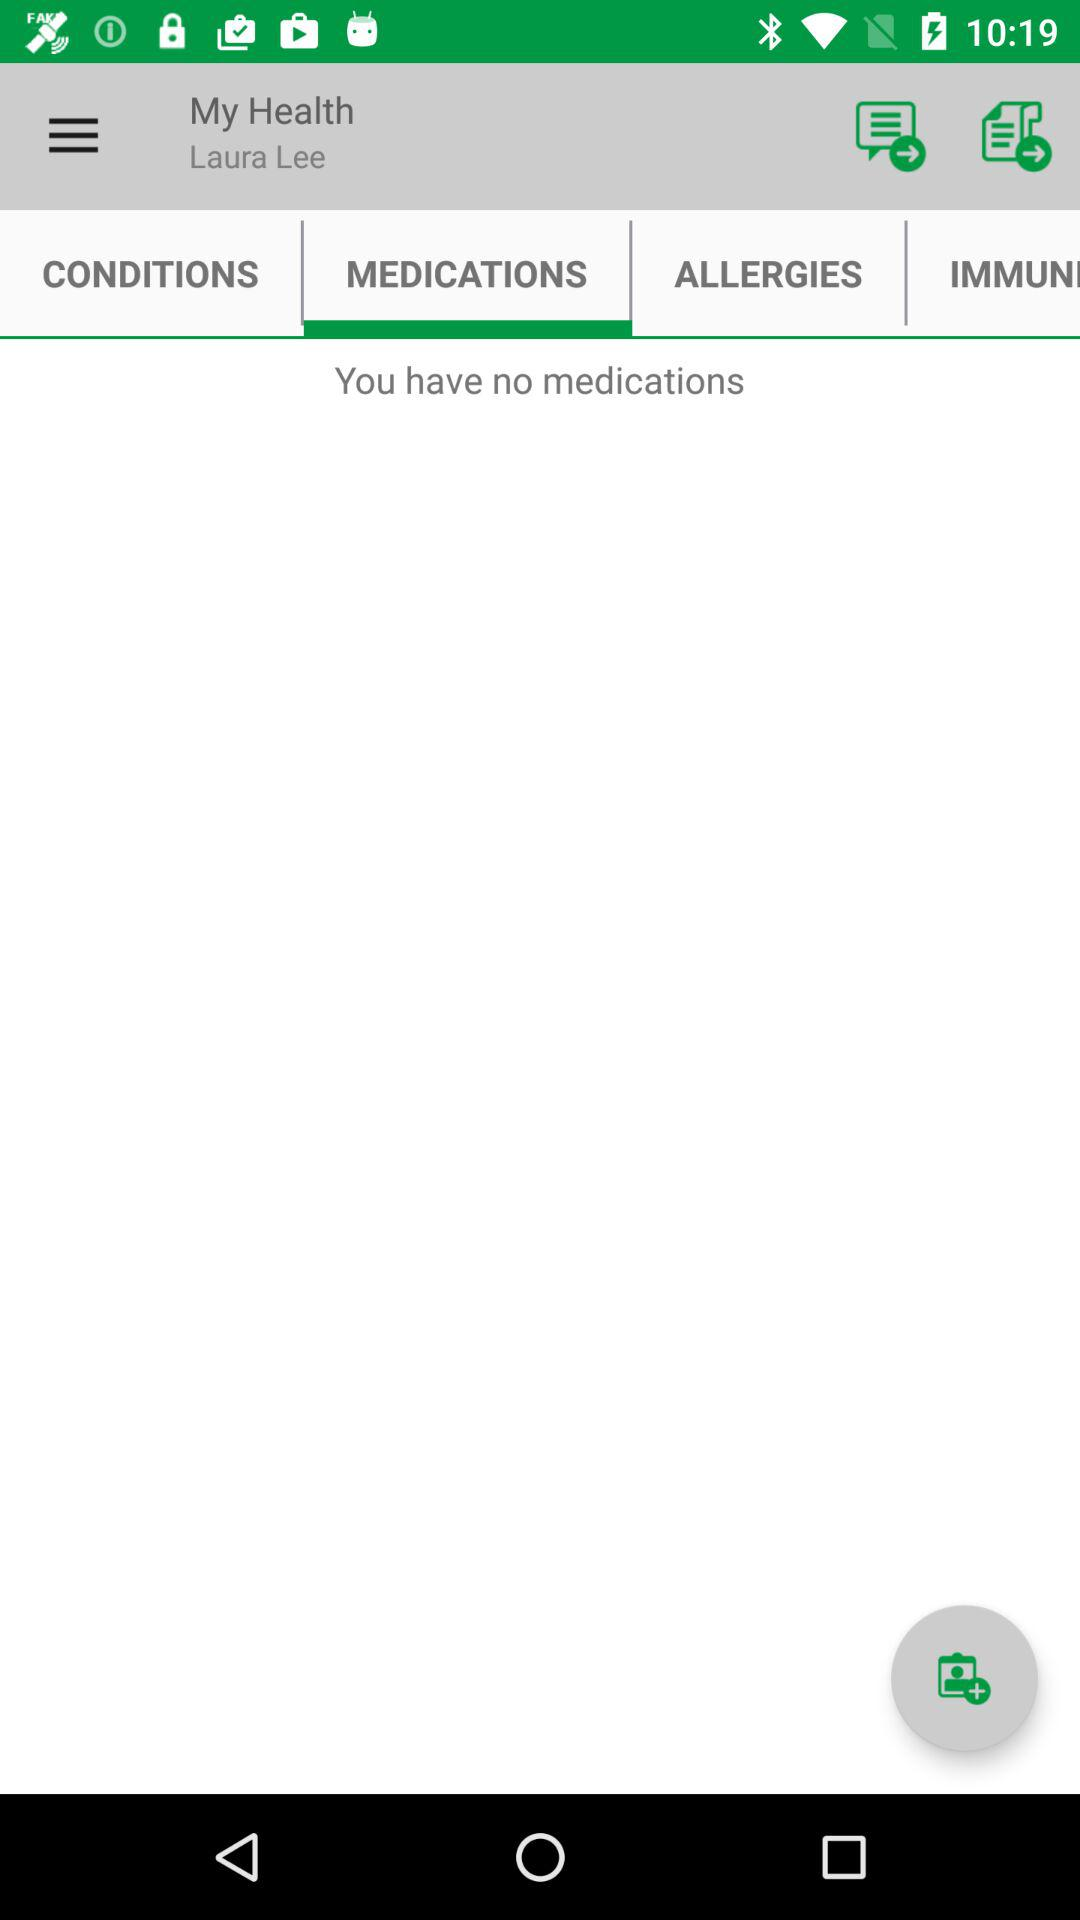What is the user name? The user name is Laura Lee. 